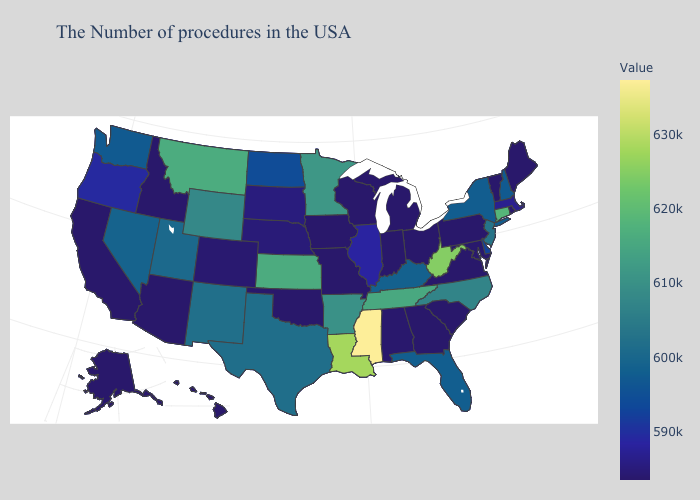Among the states that border Oregon , does Idaho have the highest value?
Short answer required. No. Among the states that border Colorado , which have the highest value?
Short answer required. Kansas. Does Ohio have a lower value than Florida?
Keep it brief. Yes. 